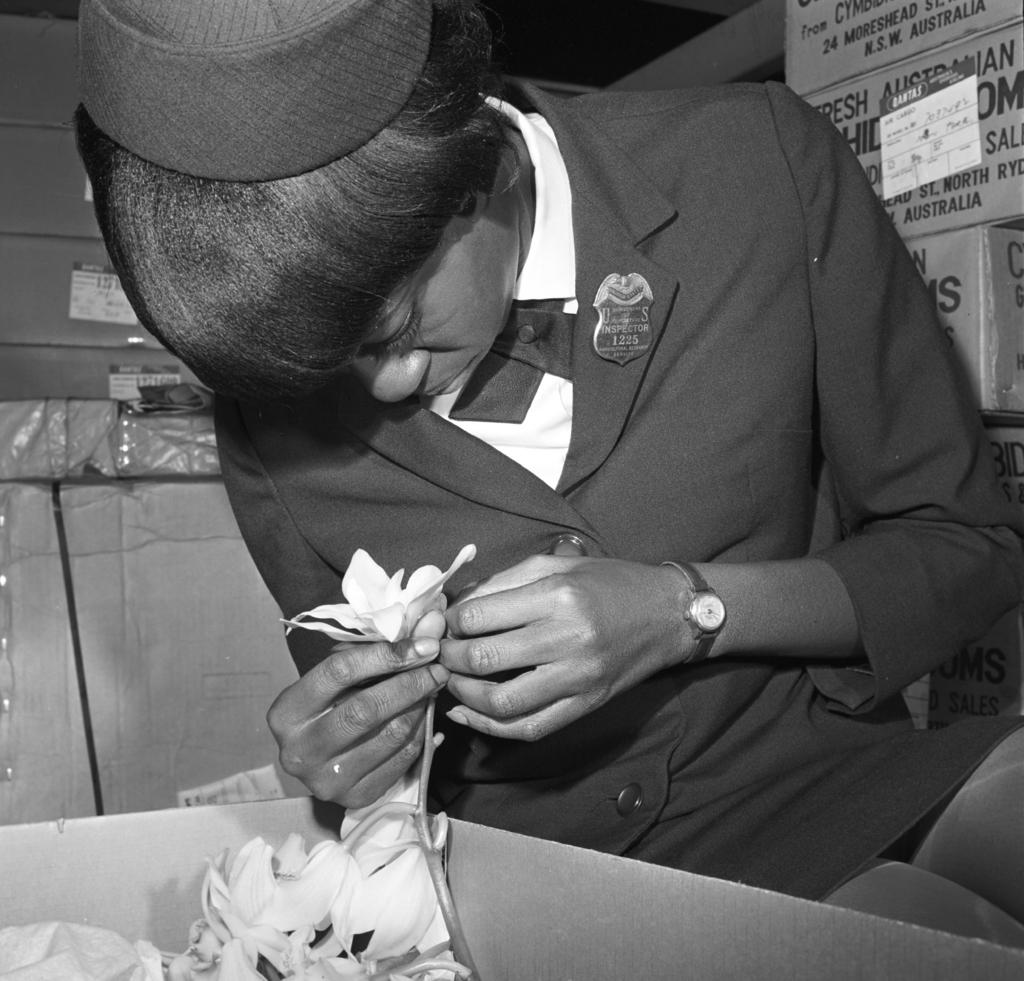What is the person in the image doing? The person is sitting in the image. What is the person holding? The person is holding a flower. What else can be seen in the image besides the person? There are flowers in a cardboard box. What can be seen in the background of the image? There are cardboard boxes in the background of the image. Can you tell me how many girls are present in the image? The image does not show any girls; it only features a person holding a flower. What type of fowl can be seen in the image? There is no fowl present in the image. 